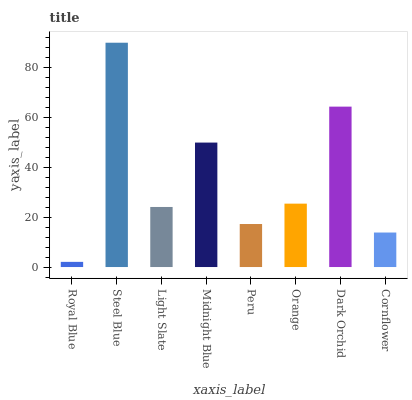Is Royal Blue the minimum?
Answer yes or no. Yes. Is Steel Blue the maximum?
Answer yes or no. Yes. Is Light Slate the minimum?
Answer yes or no. No. Is Light Slate the maximum?
Answer yes or no. No. Is Steel Blue greater than Light Slate?
Answer yes or no. Yes. Is Light Slate less than Steel Blue?
Answer yes or no. Yes. Is Light Slate greater than Steel Blue?
Answer yes or no. No. Is Steel Blue less than Light Slate?
Answer yes or no. No. Is Orange the high median?
Answer yes or no. Yes. Is Light Slate the low median?
Answer yes or no. Yes. Is Royal Blue the high median?
Answer yes or no. No. Is Cornflower the low median?
Answer yes or no. No. 